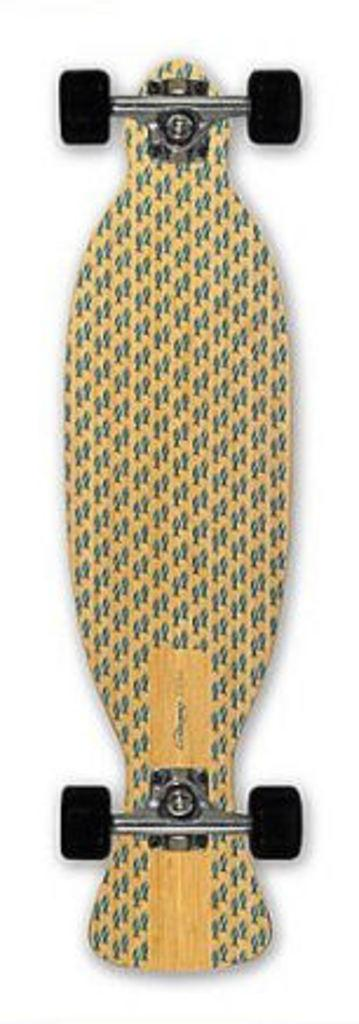What is the main object in the picture? There is a skateboard in the picture. What can be said about the color of the wheels on the skateboard? The skateboard has black color wheels. What type of memory is stored in the pickle in the image? There is no pickle present in the image, so it is not possible to determine what type of memory might be stored in it. 